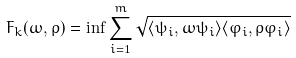<formula> <loc_0><loc_0><loc_500><loc_500>F _ { k } ( \omega , \rho ) = \inf \sum _ { i = 1 } ^ { m } \sqrt { \langle \psi _ { i } , \omega \psi _ { i } \rangle \langle \varphi _ { i } , \rho \varphi _ { i } \rangle }</formula> 